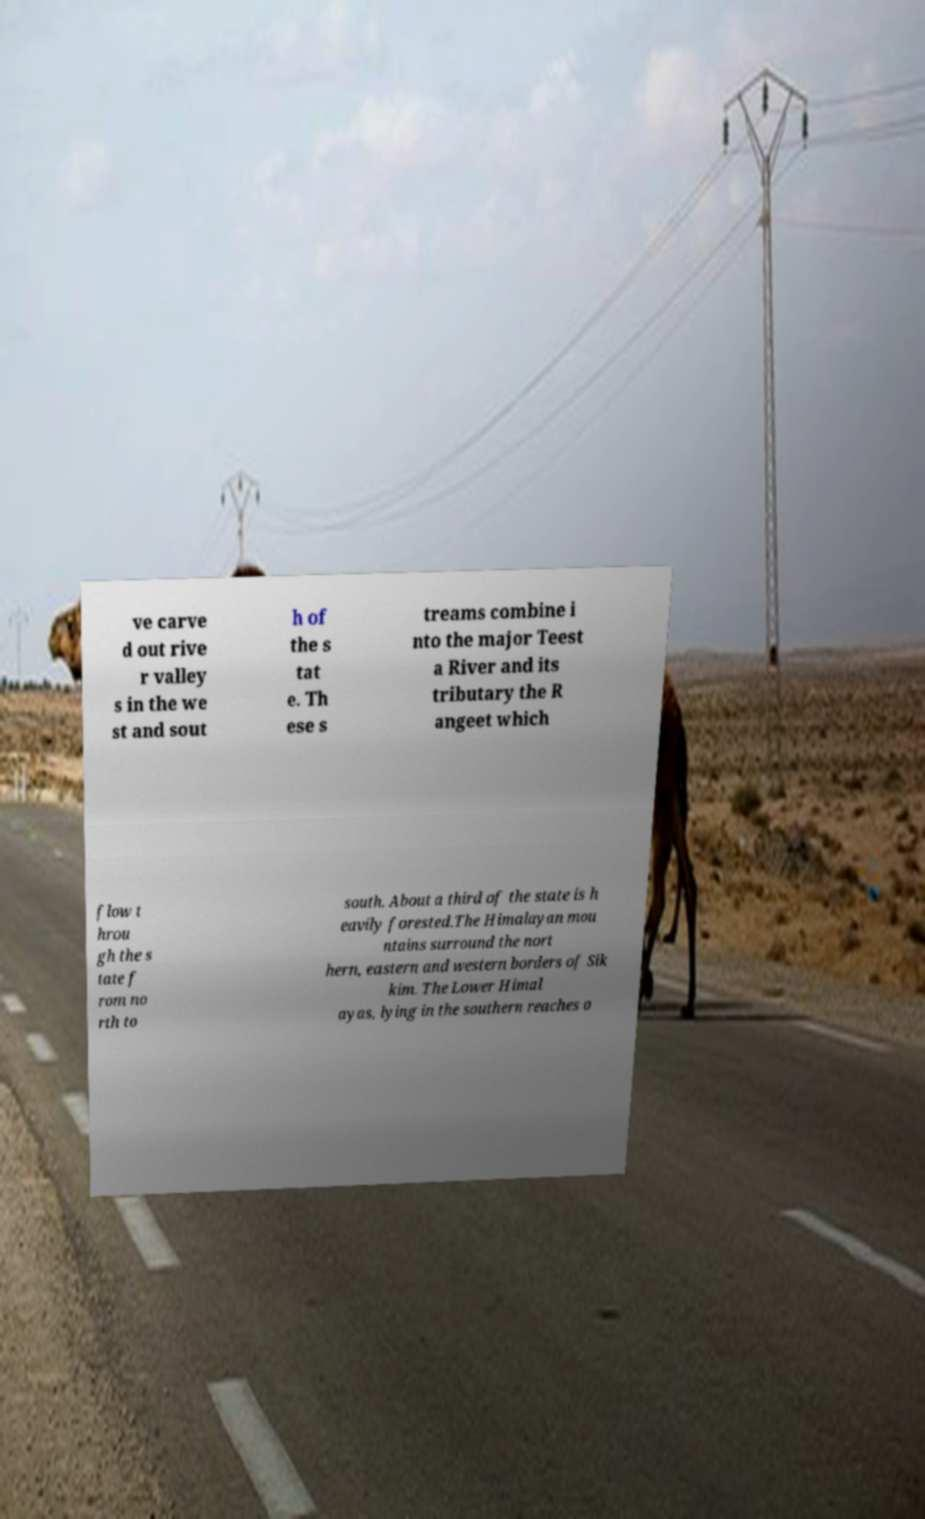I need the written content from this picture converted into text. Can you do that? ve carve d out rive r valley s in the we st and sout h of the s tat e. Th ese s treams combine i nto the major Teest a River and its tributary the R angeet which flow t hrou gh the s tate f rom no rth to south. About a third of the state is h eavily forested.The Himalayan mou ntains surround the nort hern, eastern and western borders of Sik kim. The Lower Himal ayas, lying in the southern reaches o 